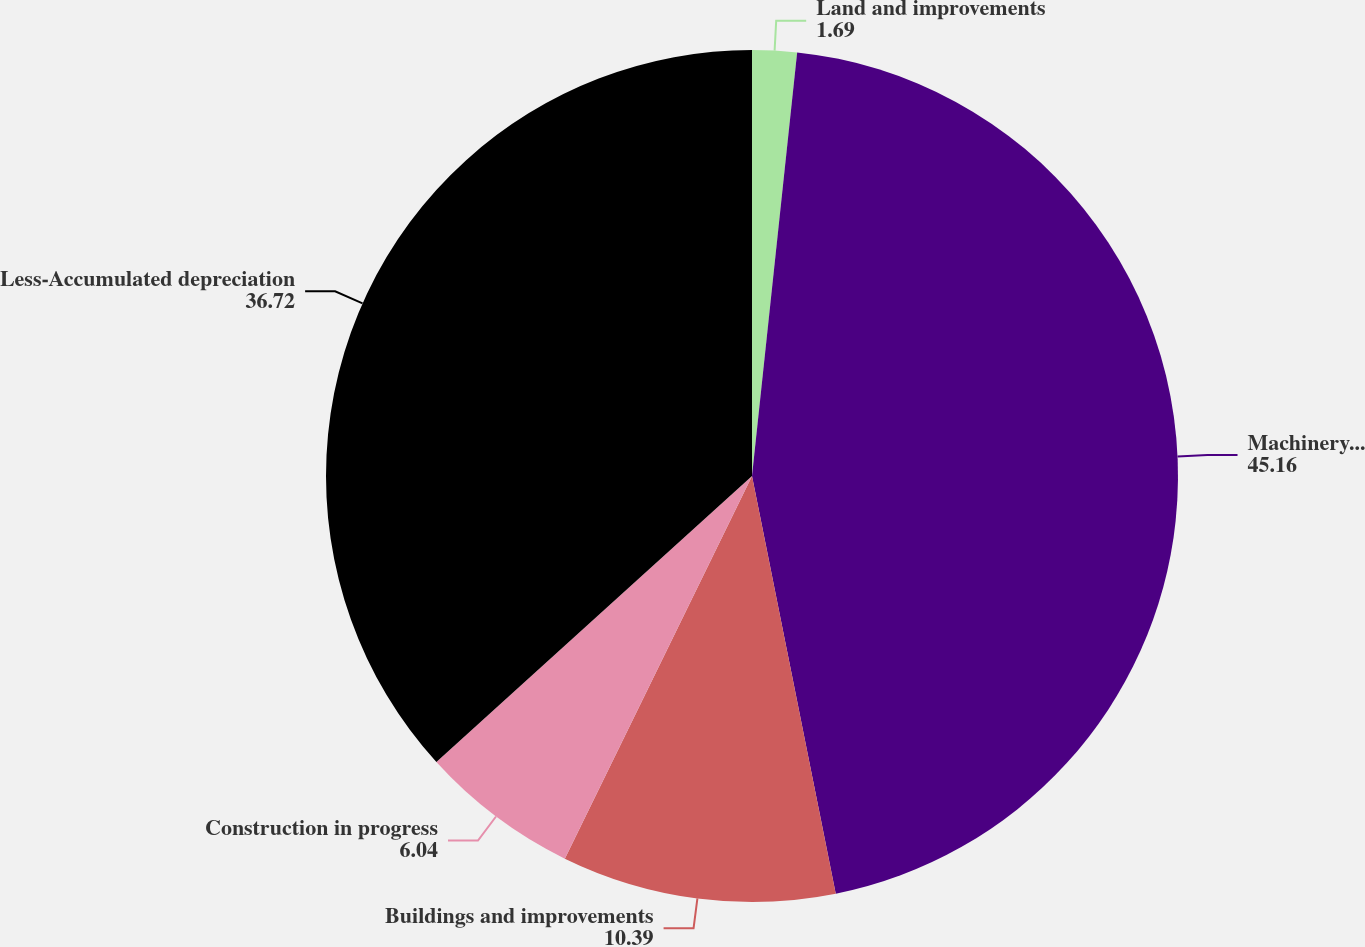<chart> <loc_0><loc_0><loc_500><loc_500><pie_chart><fcel>Land and improvements<fcel>Machinery and equipment<fcel>Buildings and improvements<fcel>Construction in progress<fcel>Less-Accumulated depreciation<nl><fcel>1.69%<fcel>45.16%<fcel>10.39%<fcel>6.04%<fcel>36.72%<nl></chart> 